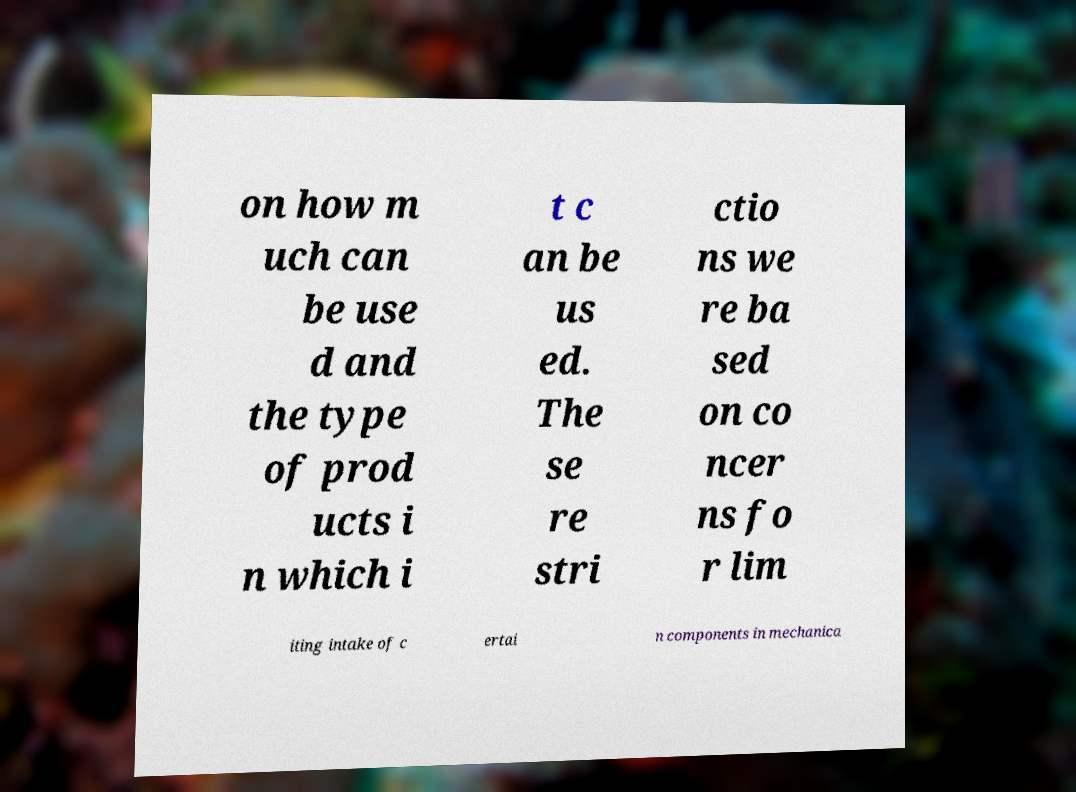There's text embedded in this image that I need extracted. Can you transcribe it verbatim? on how m uch can be use d and the type of prod ucts i n which i t c an be us ed. The se re stri ctio ns we re ba sed on co ncer ns fo r lim iting intake of c ertai n components in mechanica 